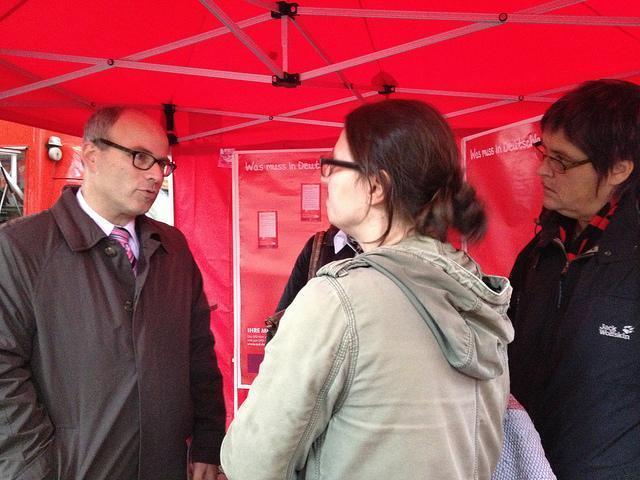How many glasses do you see?
Give a very brief answer. 3. How many people are there?
Give a very brief answer. 4. 